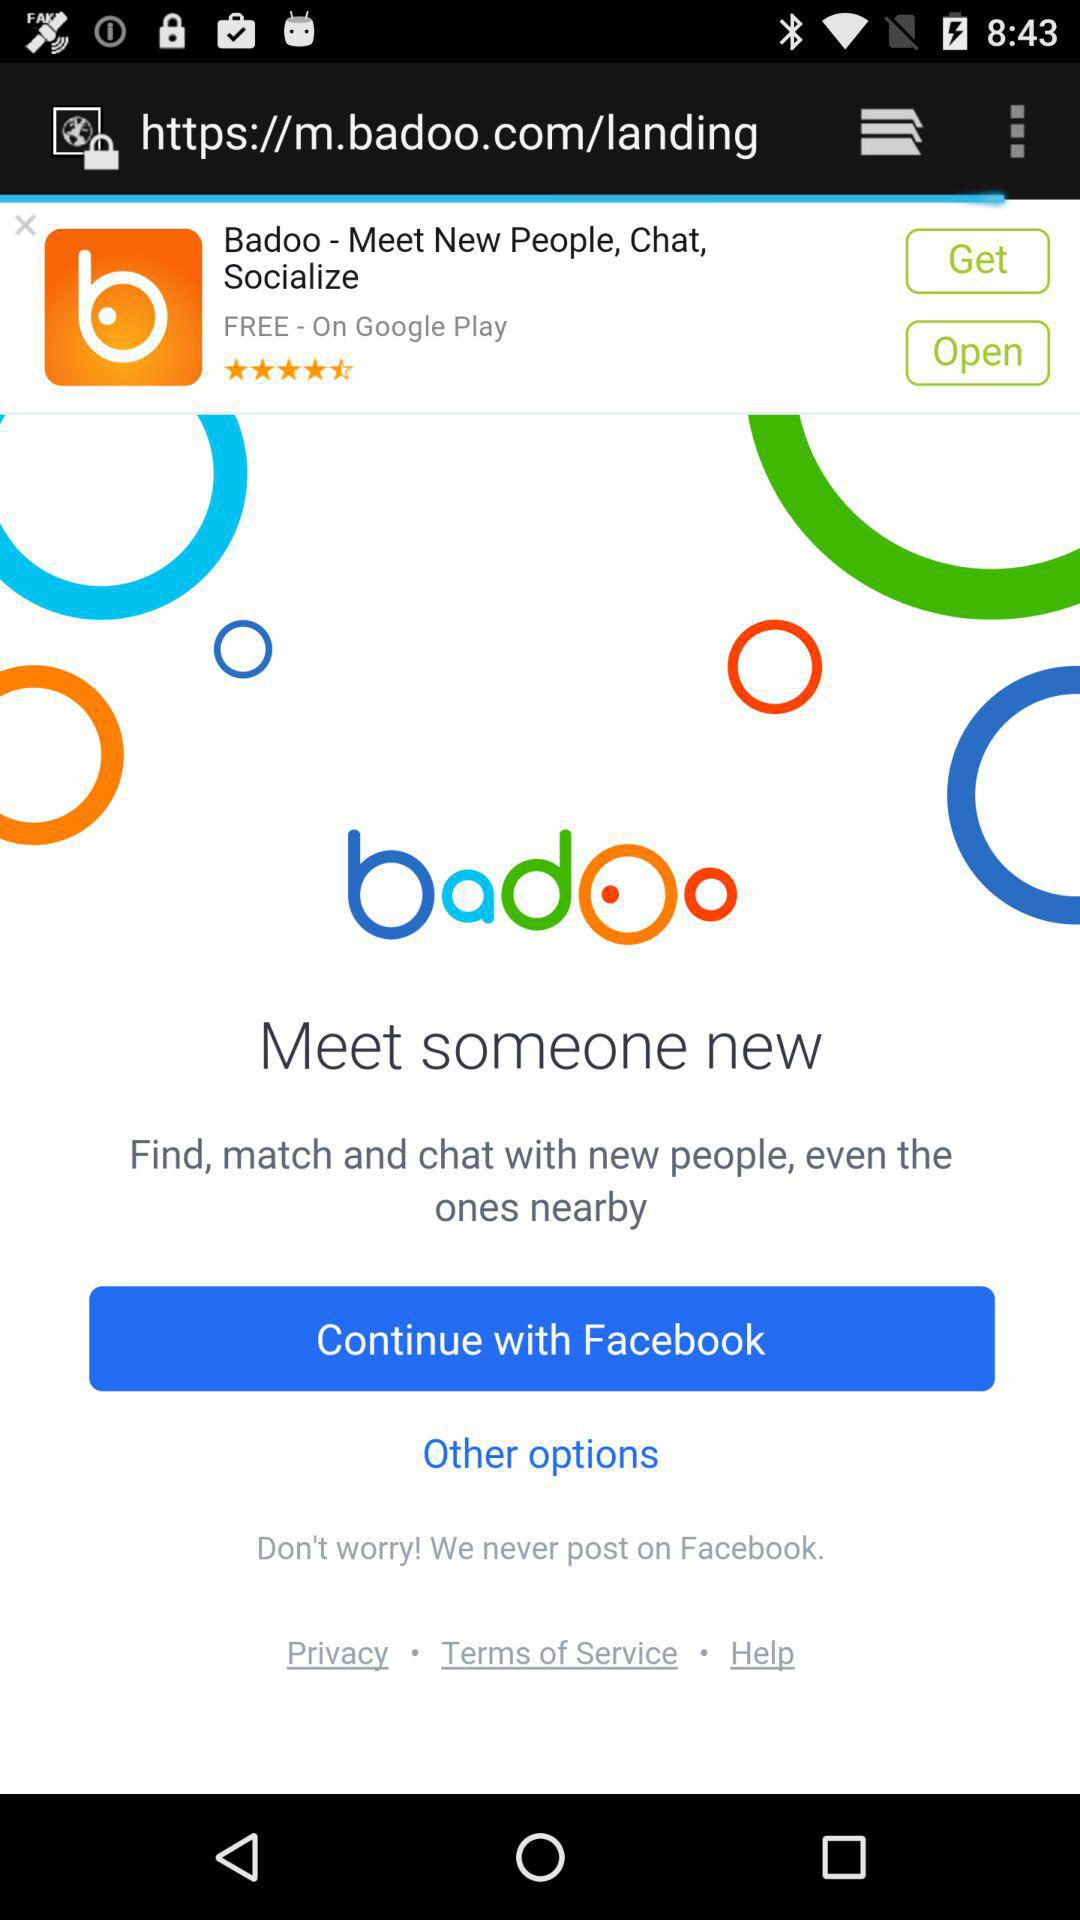What is the application name? The application name is "badoo". 